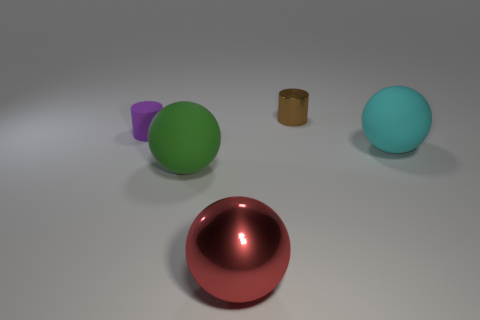Add 2 small purple rubber cylinders. How many objects exist? 7 Subtract all cylinders. How many objects are left? 3 Add 2 big blue cubes. How many big blue cubes exist? 2 Subtract 0 purple spheres. How many objects are left? 5 Subtract all large cyan rubber objects. Subtract all large green spheres. How many objects are left? 3 Add 2 brown metal things. How many brown metal things are left? 3 